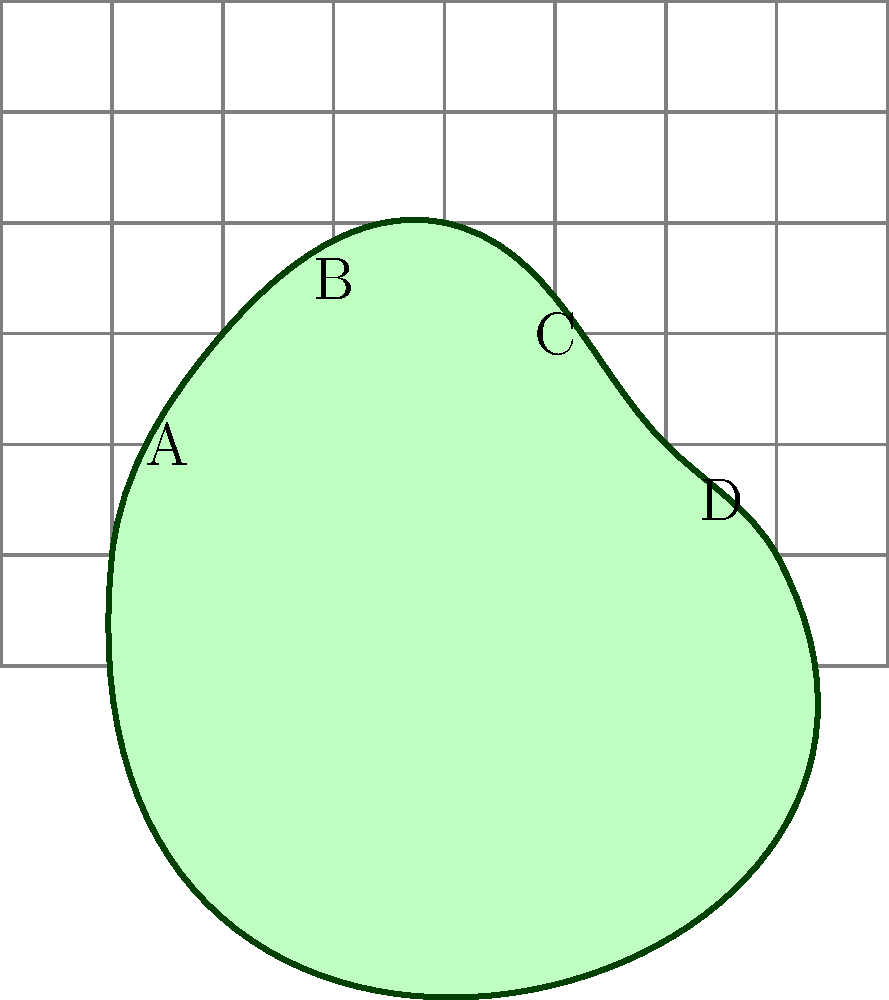You've been asked to estimate the area of an irregularly shaped planting site for a new community garden. Using the grid overlay method, where each square represents 1 square meter, what is the approximate area of the green region shown in the diagram? To estimate the area of the irregularly shaped planting site using the grid overlay method, we'll follow these steps:

1. Count the number of full squares within the green region.
2. Estimate the fraction of partial squares that are covered by the green region.
3. Add the full squares and partial square estimates together.

Step 1: Counting full squares
There are approximately 15 full squares within the green region.

Step 2: Estimating partial squares
Around the edges of the shape, we can see several partial squares. Let's estimate these:
- Top edge: About 2.5 squares
- Right edge: About 1.5 squares
- Bottom edge: About 2 squares
- Left edge: About 1 square

Total partial squares: 2.5 + 1.5 + 2 + 1 = 7 squares

Step 3: Adding full and partial squares
Total area = Full squares + Partial squares
            = 15 + 7 = 22 square meters

Therefore, the approximate area of the irregularly shaped planting site is 22 square meters.
Answer: 22 square meters 